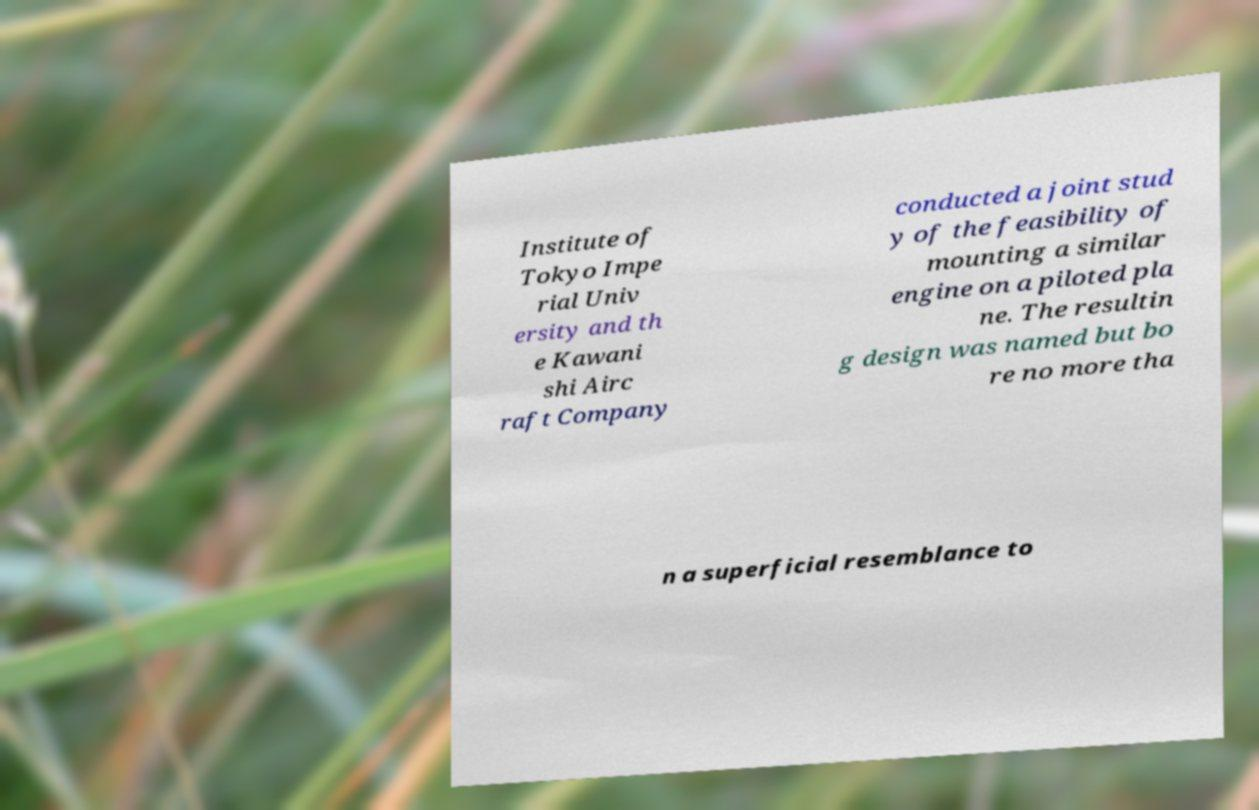For documentation purposes, I need the text within this image transcribed. Could you provide that? Institute of Tokyo Impe rial Univ ersity and th e Kawani shi Airc raft Company conducted a joint stud y of the feasibility of mounting a similar engine on a piloted pla ne. The resultin g design was named but bo re no more tha n a superficial resemblance to 